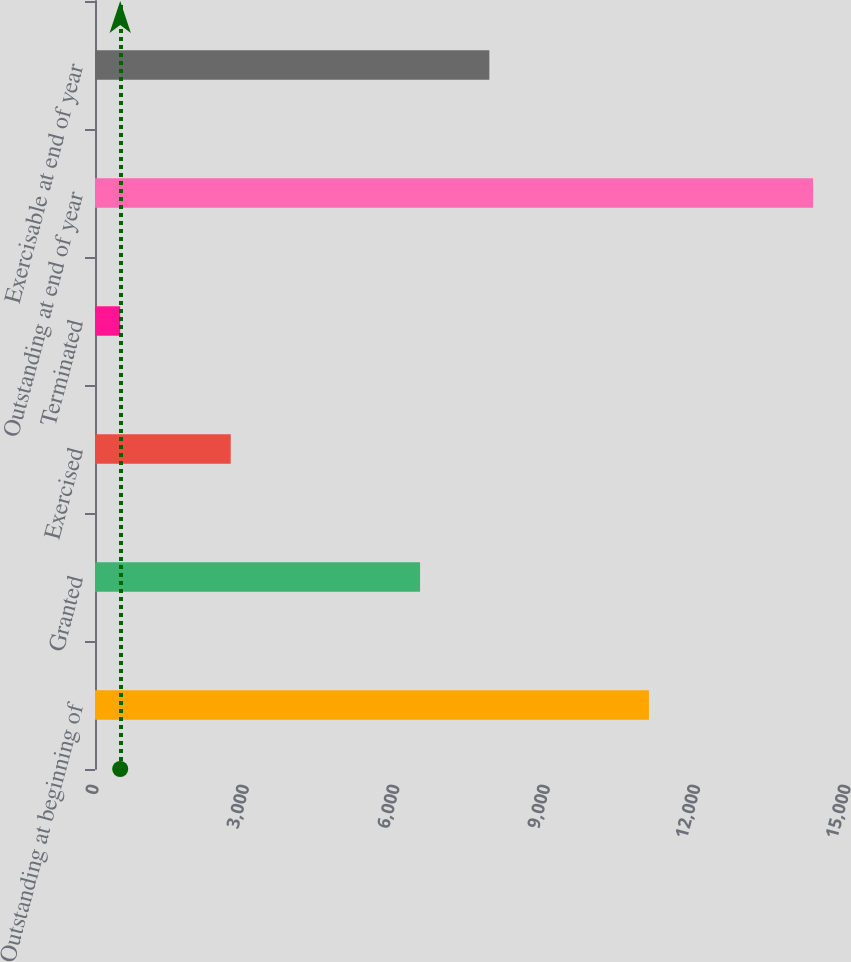Convert chart. <chart><loc_0><loc_0><loc_500><loc_500><bar_chart><fcel>Outstanding at beginning of<fcel>Granted<fcel>Exercised<fcel>Terminated<fcel>Outstanding at end of year<fcel>Exercisable at end of year<nl><fcel>11049<fcel>6484<fcel>2707<fcel>503<fcel>14323<fcel>7866<nl></chart> 